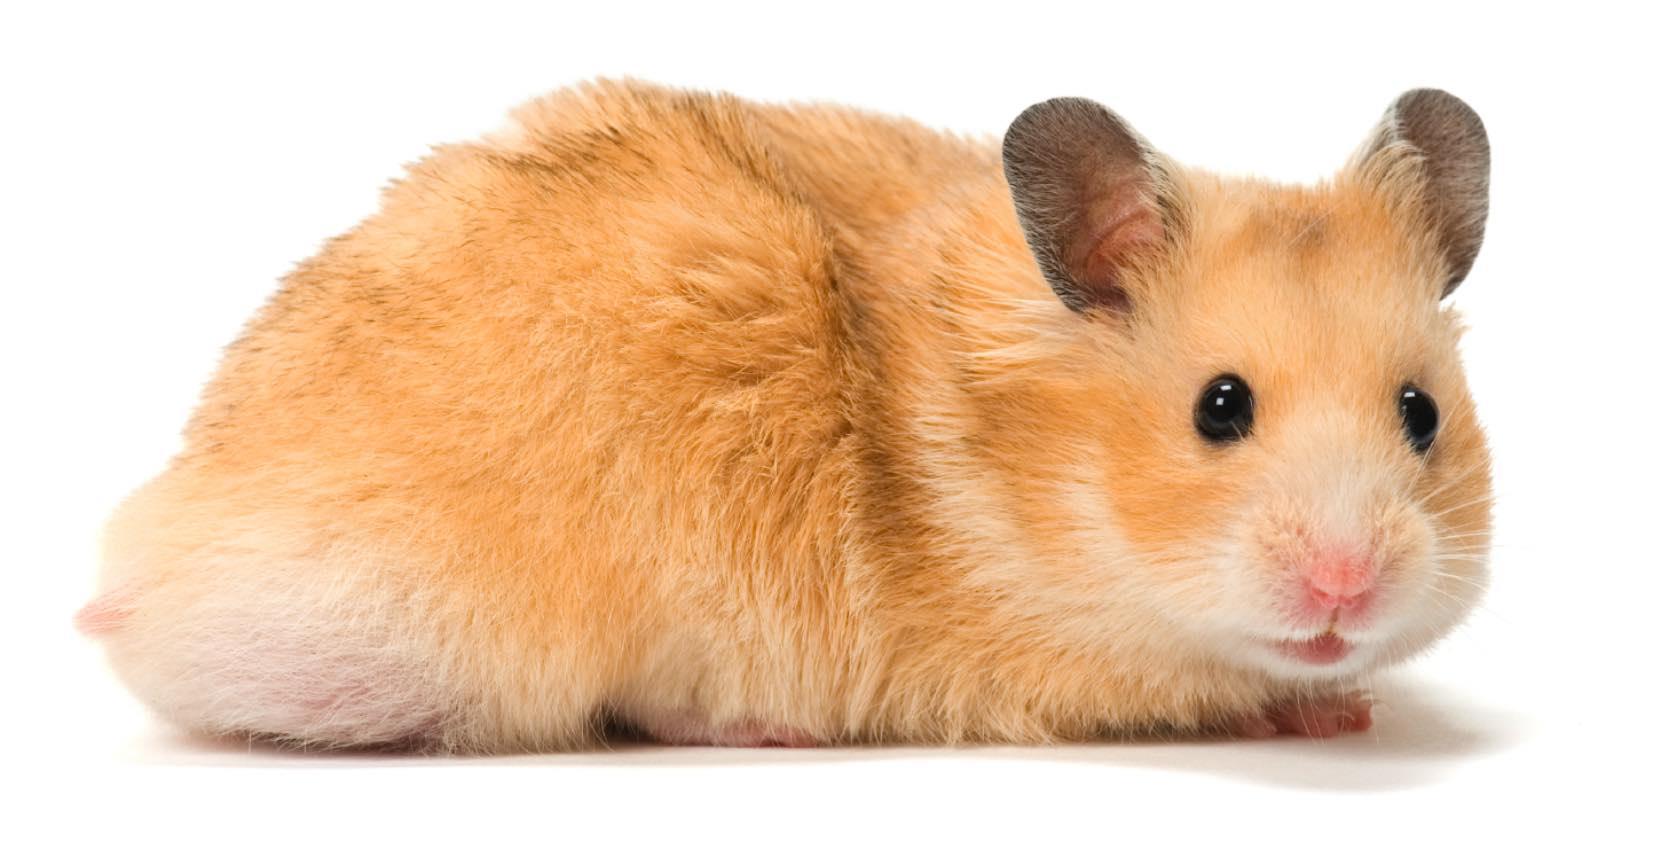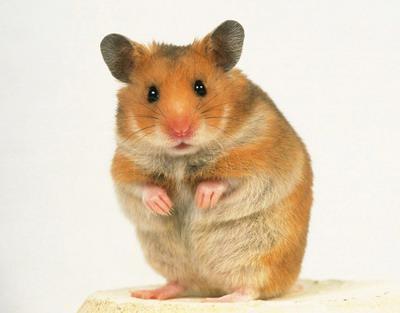The first image is the image on the left, the second image is the image on the right. Examine the images to the left and right. Is the description "There are fewer than four hamsters." accurate? Answer yes or no. Yes. The first image is the image on the left, the second image is the image on the right. Considering the images on both sides, is "In one of the images, there is an orange food item being eaten." valid? Answer yes or no. No. 